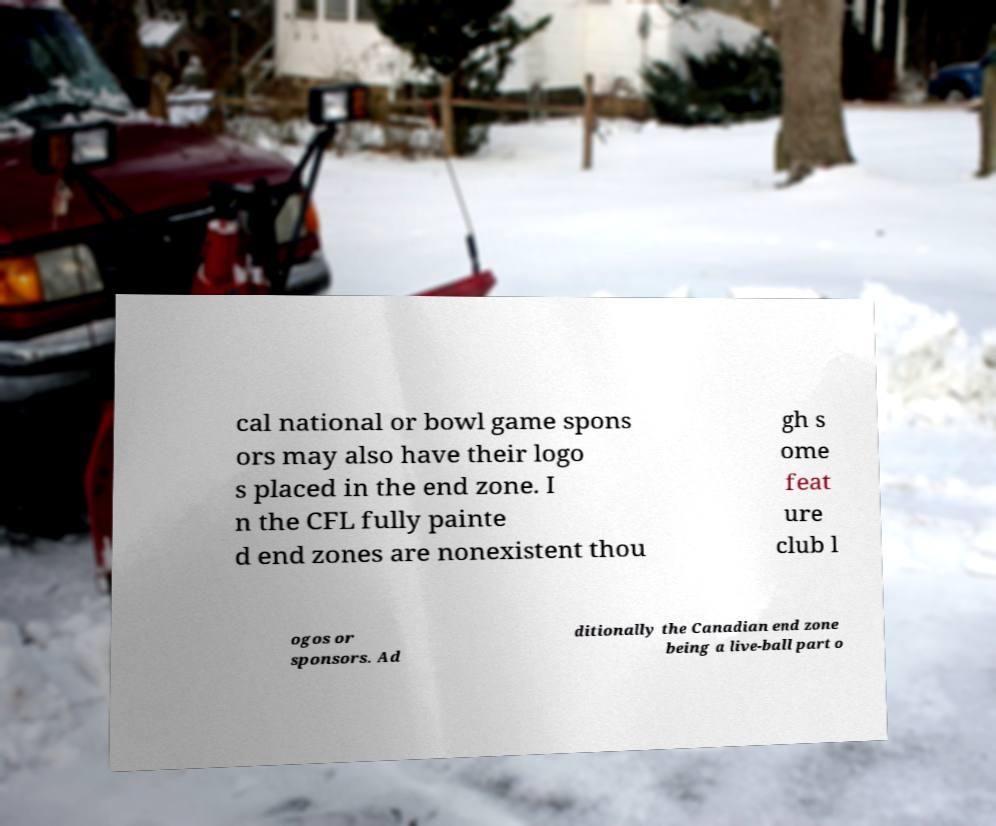Can you read and provide the text displayed in the image?This photo seems to have some interesting text. Can you extract and type it out for me? cal national or bowl game spons ors may also have their logo s placed in the end zone. I n the CFL fully painte d end zones are nonexistent thou gh s ome feat ure club l ogos or sponsors. Ad ditionally the Canadian end zone being a live-ball part o 